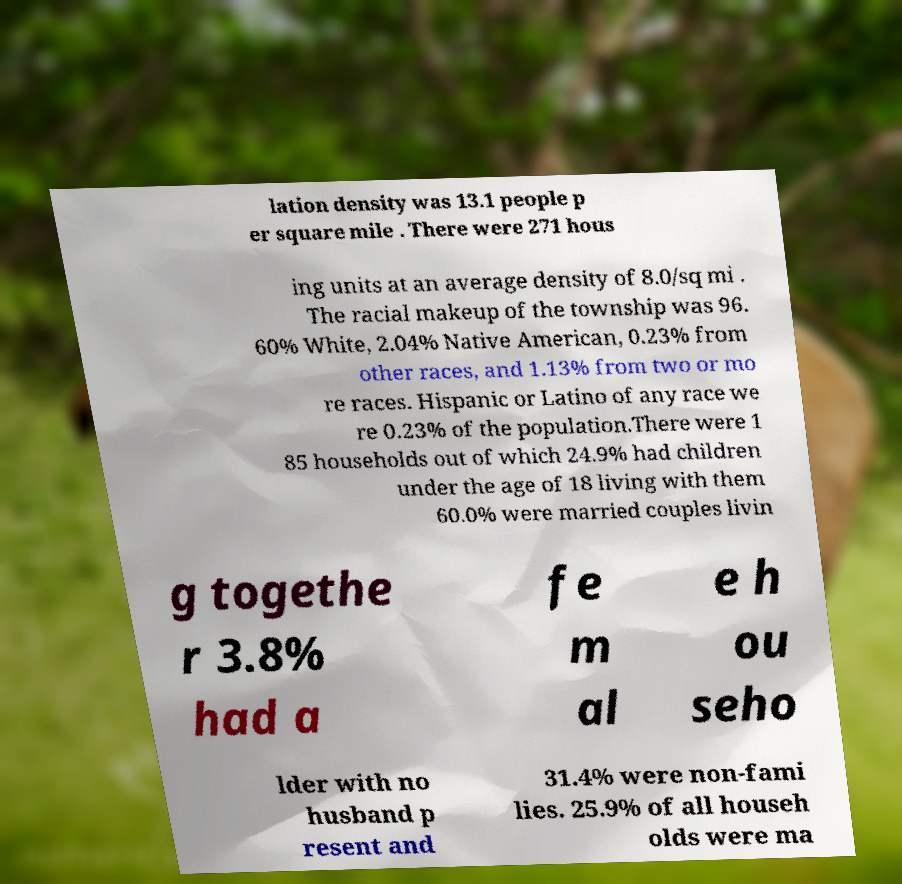Could you assist in decoding the text presented in this image and type it out clearly? lation density was 13.1 people p er square mile . There were 271 hous ing units at an average density of 8.0/sq mi . The racial makeup of the township was 96. 60% White, 2.04% Native American, 0.23% from other races, and 1.13% from two or mo re races. Hispanic or Latino of any race we re 0.23% of the population.There were 1 85 households out of which 24.9% had children under the age of 18 living with them 60.0% were married couples livin g togethe r 3.8% had a fe m al e h ou seho lder with no husband p resent and 31.4% were non-fami lies. 25.9% of all househ olds were ma 